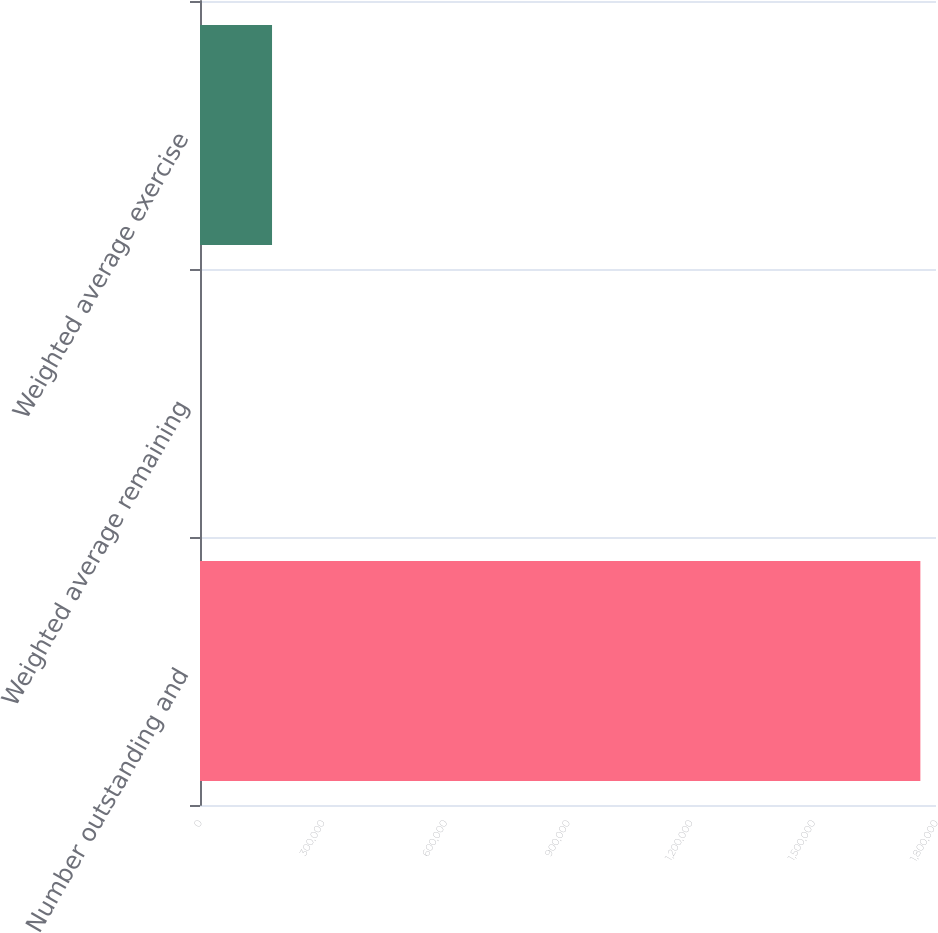Convert chart to OTSL. <chart><loc_0><loc_0><loc_500><loc_500><bar_chart><fcel>Number outstanding and<fcel>Weighted average remaining<fcel>Weighted average exercise<nl><fcel>1.76177e+06<fcel>1.9<fcel>176179<nl></chart> 